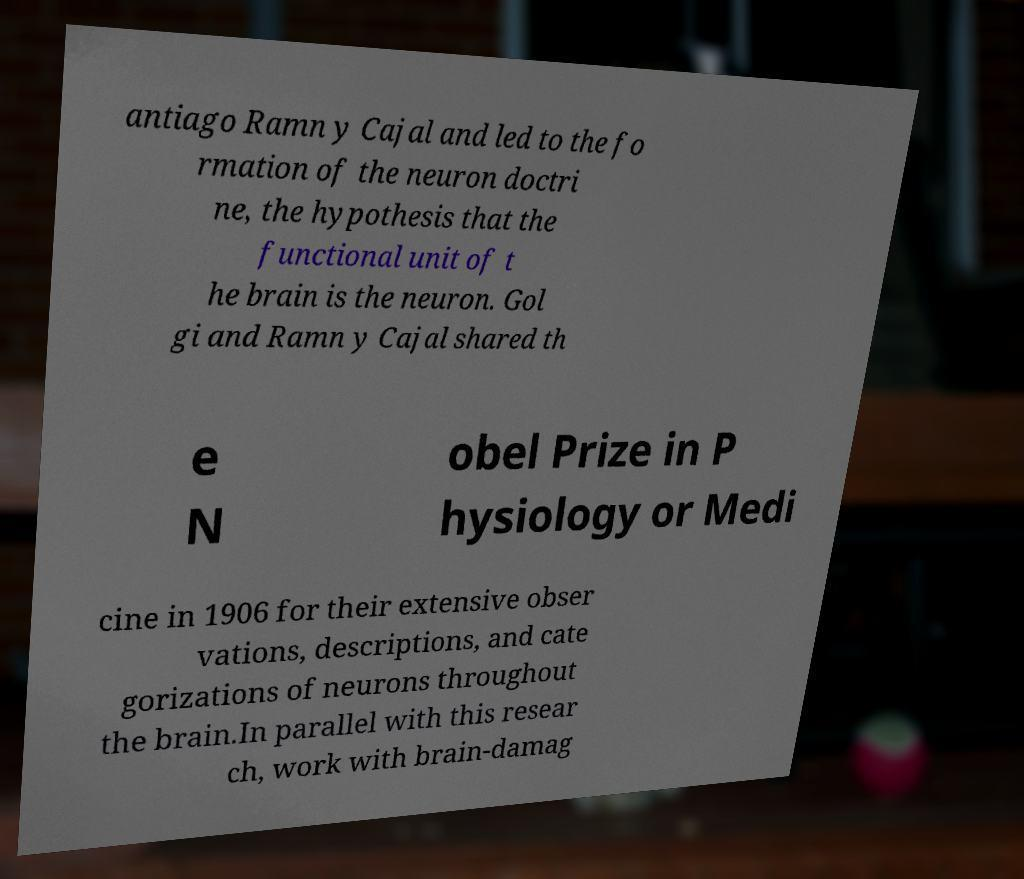Please identify and transcribe the text found in this image. antiago Ramn y Cajal and led to the fo rmation of the neuron doctri ne, the hypothesis that the functional unit of t he brain is the neuron. Gol gi and Ramn y Cajal shared th e N obel Prize in P hysiology or Medi cine in 1906 for their extensive obser vations, descriptions, and cate gorizations of neurons throughout the brain.In parallel with this resear ch, work with brain-damag 